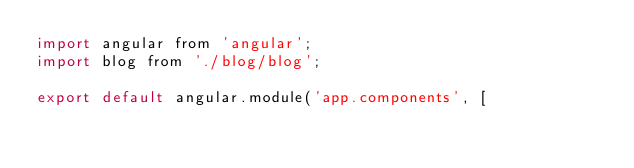<code> <loc_0><loc_0><loc_500><loc_500><_JavaScript_>import angular from 'angular';
import blog from './blog/blog';

export default angular.module('app.components', [</code> 